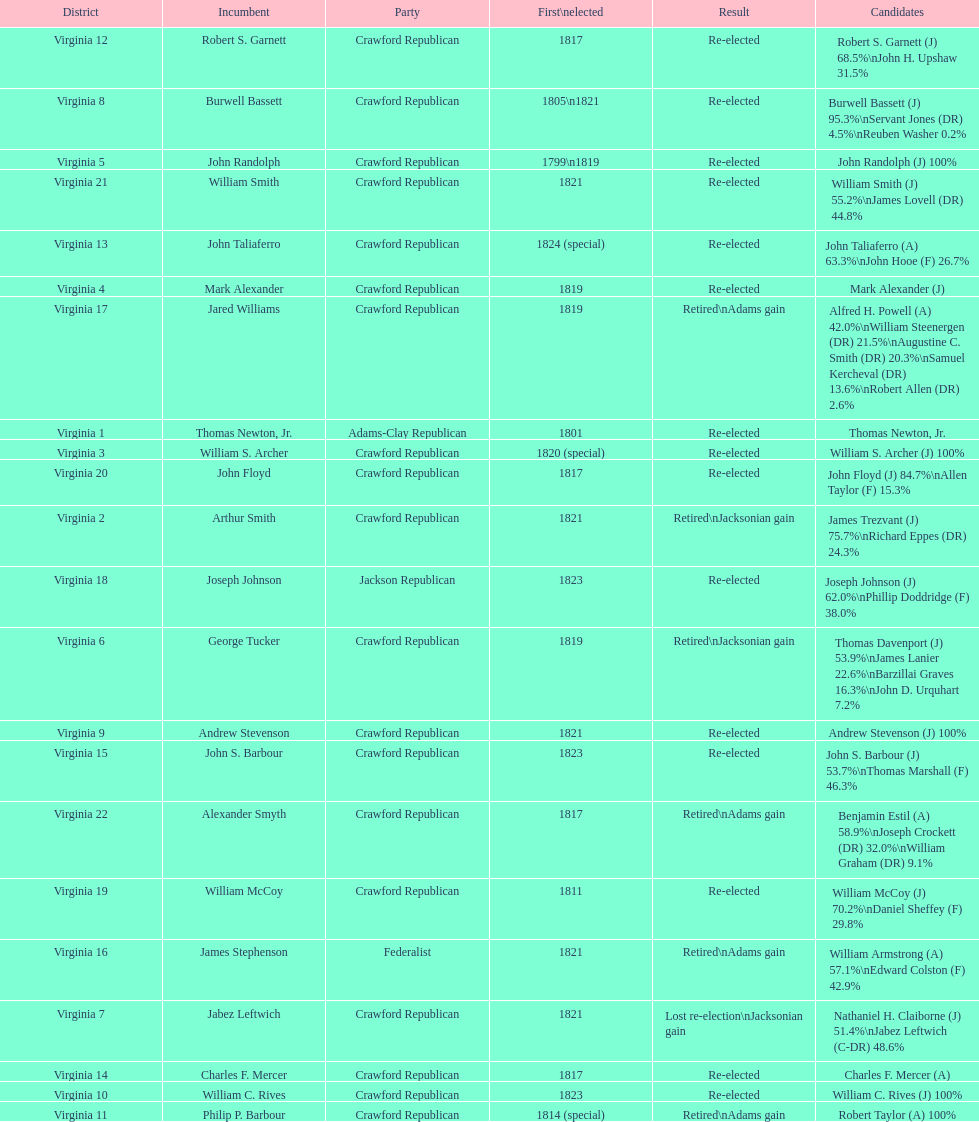Name the only candidate that was first elected in 1811. William McCoy. 